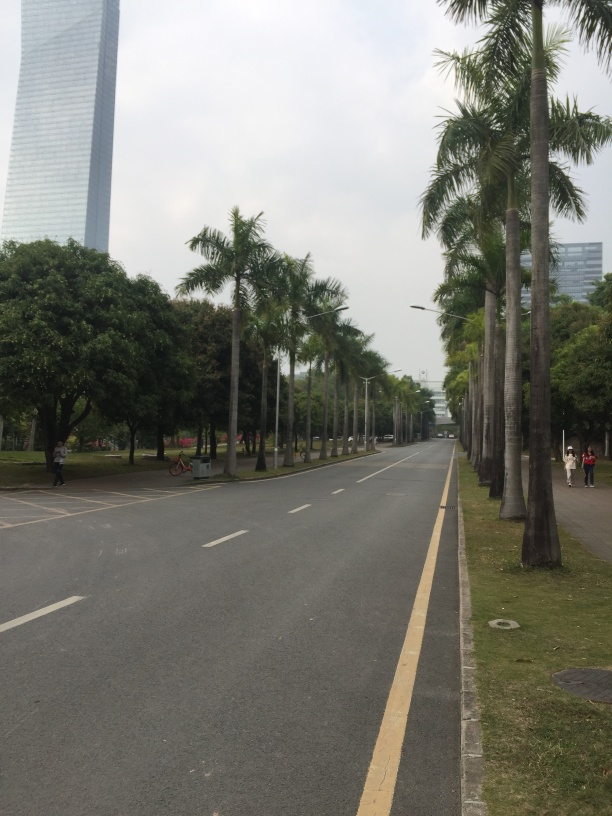How would you rate the overall quality of this image?
A. Good
B. Unsatisfactory
C. Mediocre
D. Poor
Answer with the option's letter from the given choices directly.
 A. 